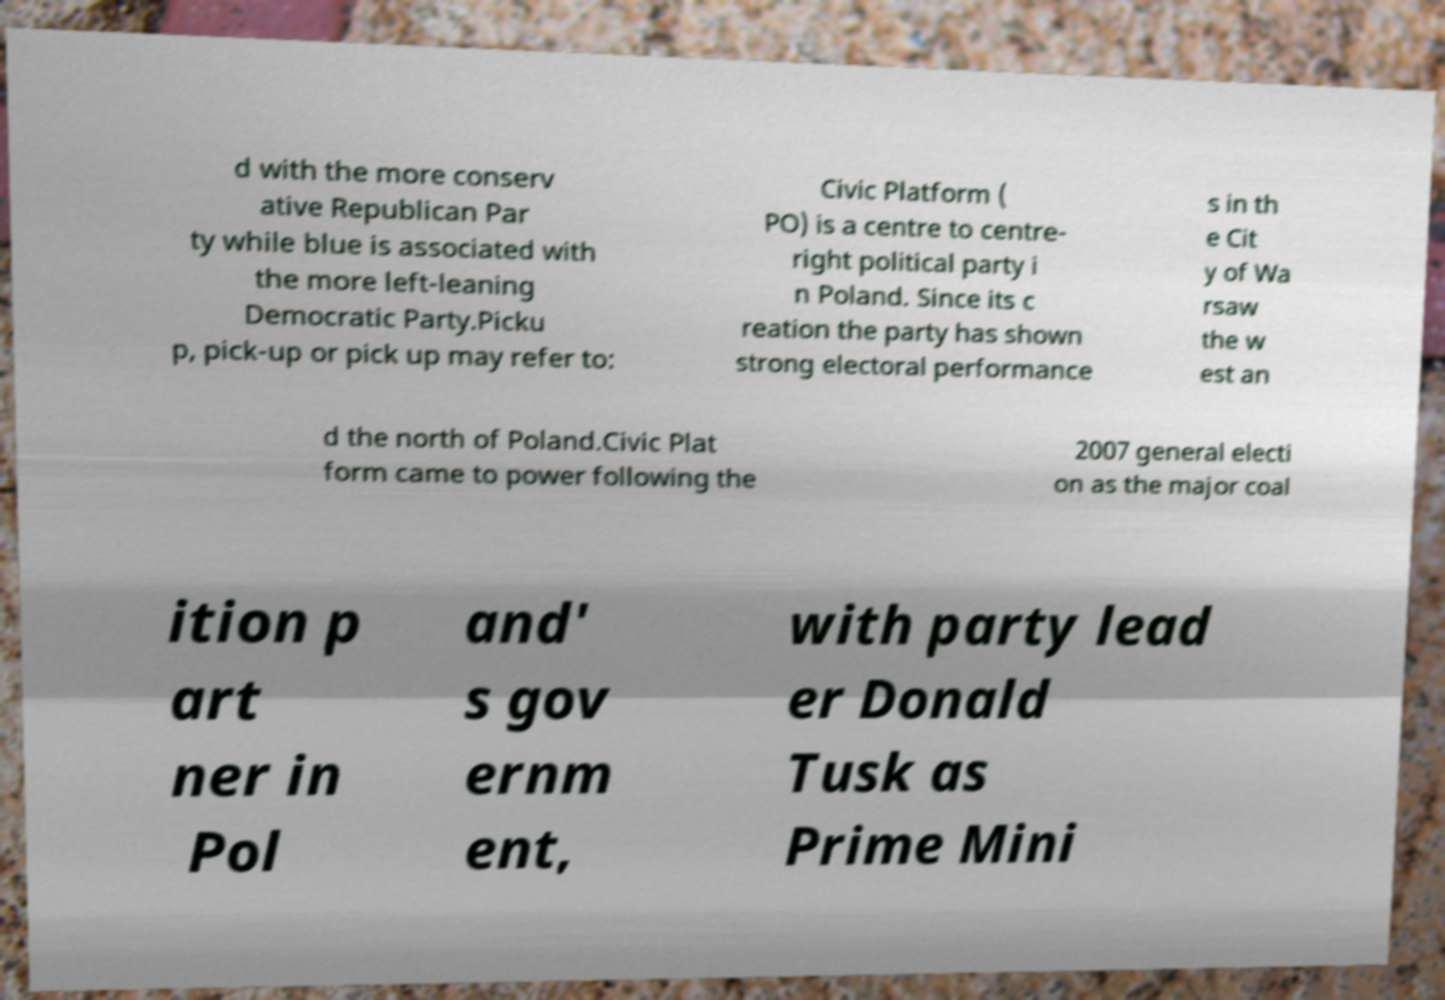Can you accurately transcribe the text from the provided image for me? d with the more conserv ative Republican Par ty while blue is associated with the more left-leaning Democratic Party.Picku p, pick-up or pick up may refer to: Civic Platform ( PO) is a centre to centre- right political party i n Poland. Since its c reation the party has shown strong electoral performance s in th e Cit y of Wa rsaw the w est an d the north of Poland.Civic Plat form came to power following the 2007 general electi on as the major coal ition p art ner in Pol and' s gov ernm ent, with party lead er Donald Tusk as Prime Mini 